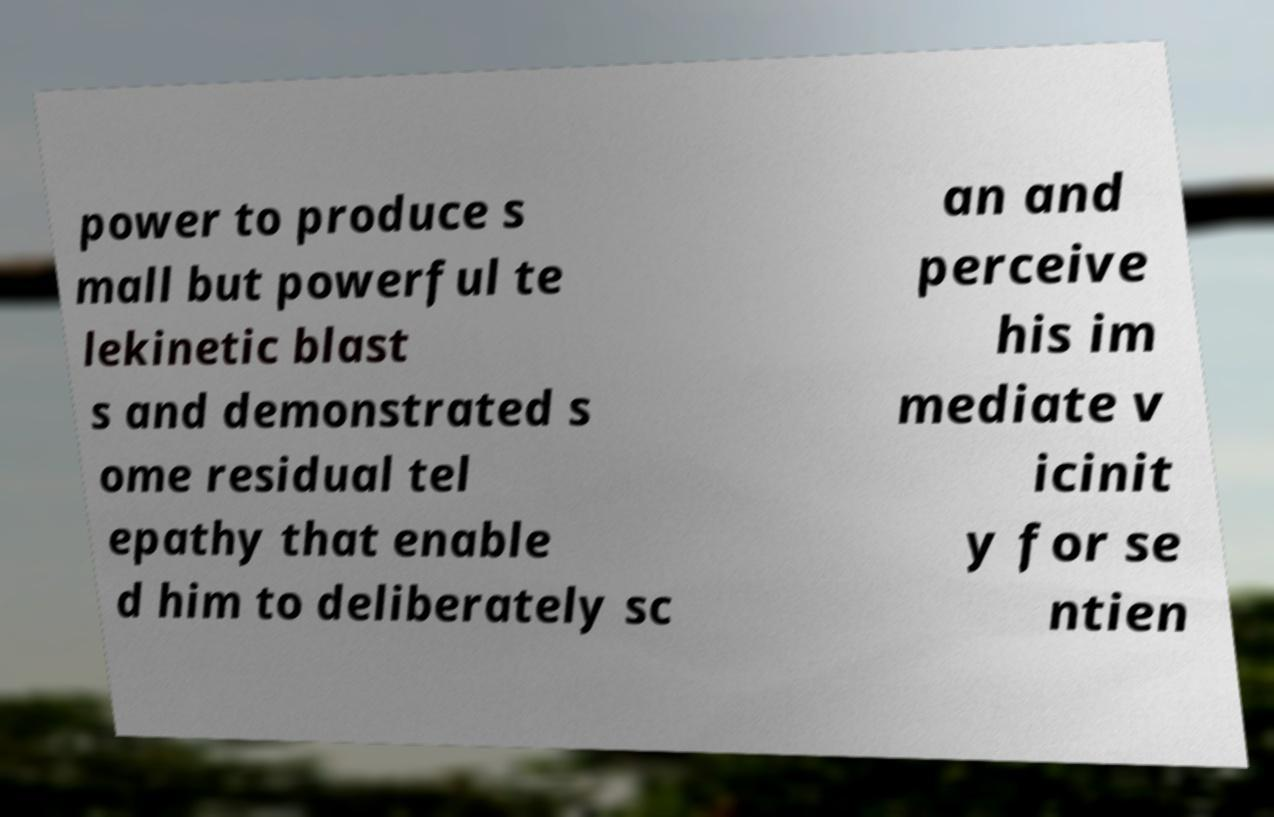What messages or text are displayed in this image? I need them in a readable, typed format. power to produce s mall but powerful te lekinetic blast s and demonstrated s ome residual tel epathy that enable d him to deliberately sc an and perceive his im mediate v icinit y for se ntien 